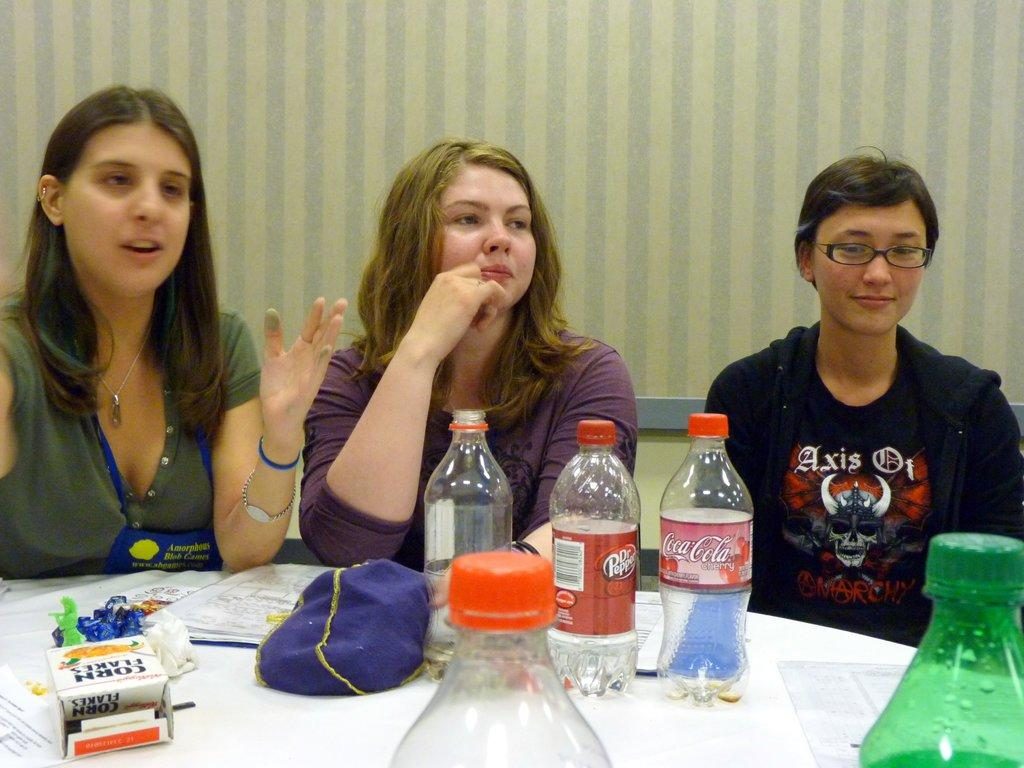What are the women doing in the image? The women are sitting on a bench in the image. What is located in front of the bench? There is a table in front of the bench. What items can be seen on the table? There are bottles and papers on the table. What is visible behind the bench? There is a wall behind the bench. What type of ship can be seen sailing in the background of the image? There is no ship visible in the image; it only features women sitting on a bench, a table, bottles, papers, and a wall. 